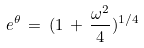Convert formula to latex. <formula><loc_0><loc_0><loc_500><loc_500>e ^ { \theta } \, = \, ( 1 \, + \, \frac { \omega ^ { 2 } } { 4 } ) ^ { 1 / 4 }</formula> 